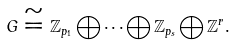Convert formula to latex. <formula><loc_0><loc_0><loc_500><loc_500>G \cong \mathbb { Z } _ { p _ { 1 } } \bigoplus \cdots \bigoplus \mathbb { Z } _ { p _ { s } } \bigoplus \mathbb { Z } ^ { r } .</formula> 